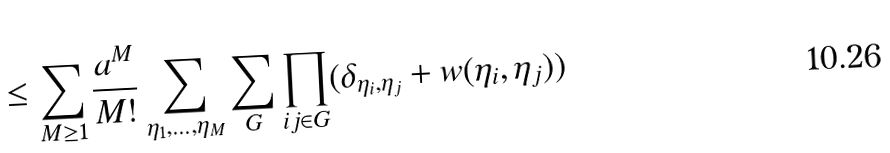Convert formula to latex. <formula><loc_0><loc_0><loc_500><loc_500>\leq \sum _ { M \geq 1 } \frac { a ^ { M } } { M ! } \sum _ { \eta _ { 1 } , \dots , \eta _ { M } } \sum _ { G } \prod _ { i j \in G } ( \delta _ { \eta _ { i } , \eta _ { j } } + w ( \eta _ { i } , \eta _ { j } ) )</formula> 